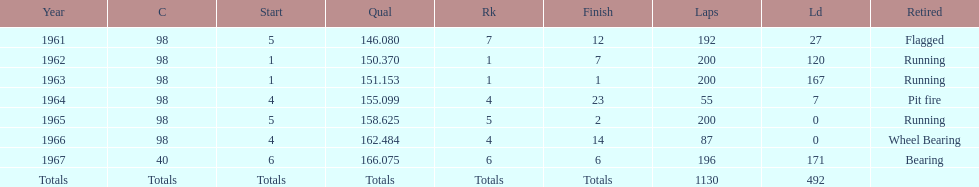What is the most common cause for a retired car? Running. 